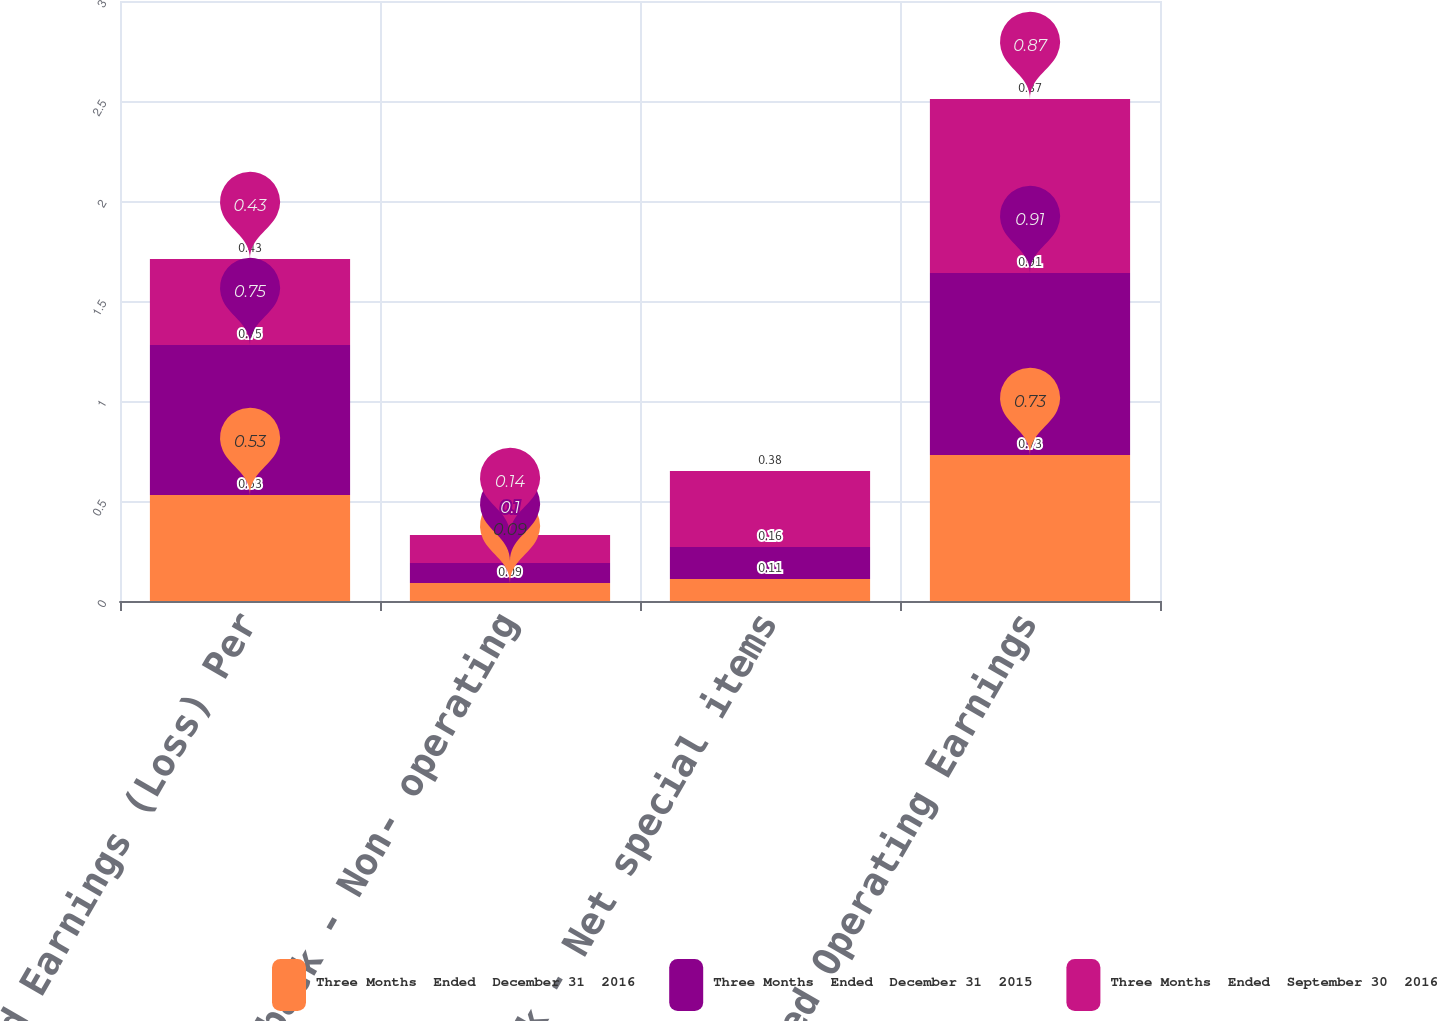Convert chart. <chart><loc_0><loc_0><loc_500><loc_500><stacked_bar_chart><ecel><fcel>Diluted Earnings (Loss) Per<fcel>Add back - Non- operating<fcel>Add back - Net special items<fcel>Adjusted Operating Earnings<nl><fcel>Three Months  Ended  December 31  2016<fcel>0.53<fcel>0.09<fcel>0.11<fcel>0.73<nl><fcel>Three Months  Ended  December 31  2015<fcel>0.75<fcel>0.1<fcel>0.16<fcel>0.91<nl><fcel>Three Months  Ended  September 30  2016<fcel>0.43<fcel>0.14<fcel>0.38<fcel>0.87<nl></chart> 